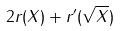<formula> <loc_0><loc_0><loc_500><loc_500>2 r ( X ) + r ^ { \prime } ( \sqrt { X } )</formula> 